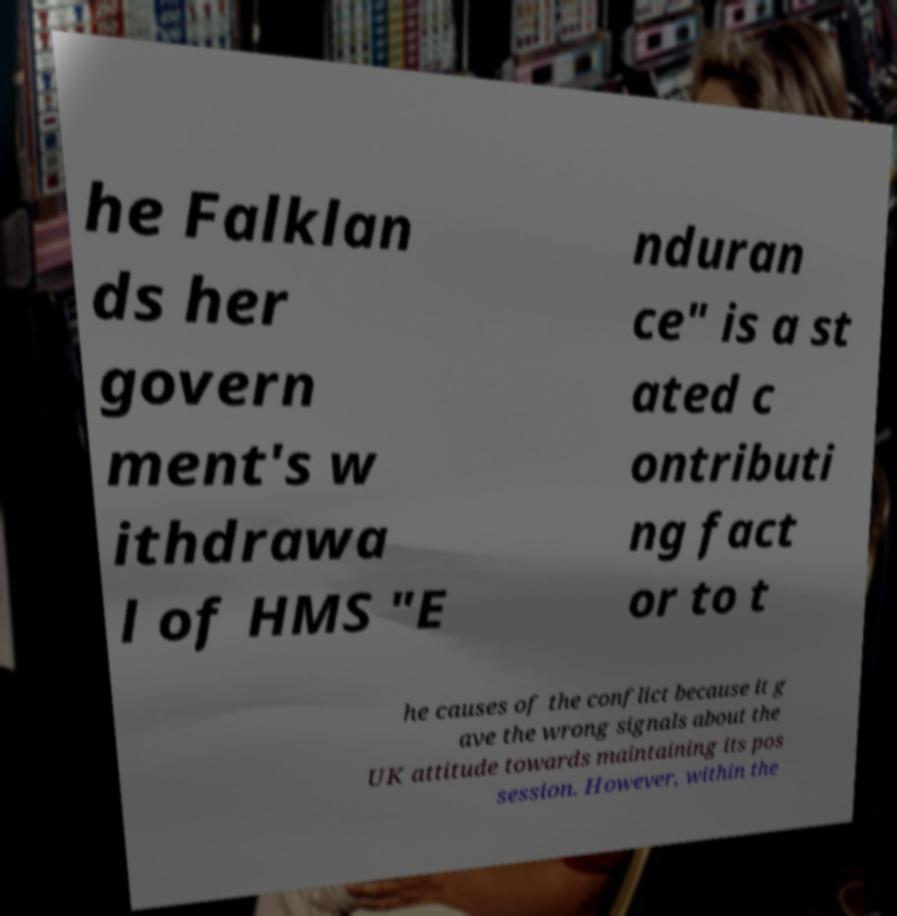Could you assist in decoding the text presented in this image and type it out clearly? he Falklan ds her govern ment's w ithdrawa l of HMS "E nduran ce" is a st ated c ontributi ng fact or to t he causes of the conflict because it g ave the wrong signals about the UK attitude towards maintaining its pos session. However, within the 